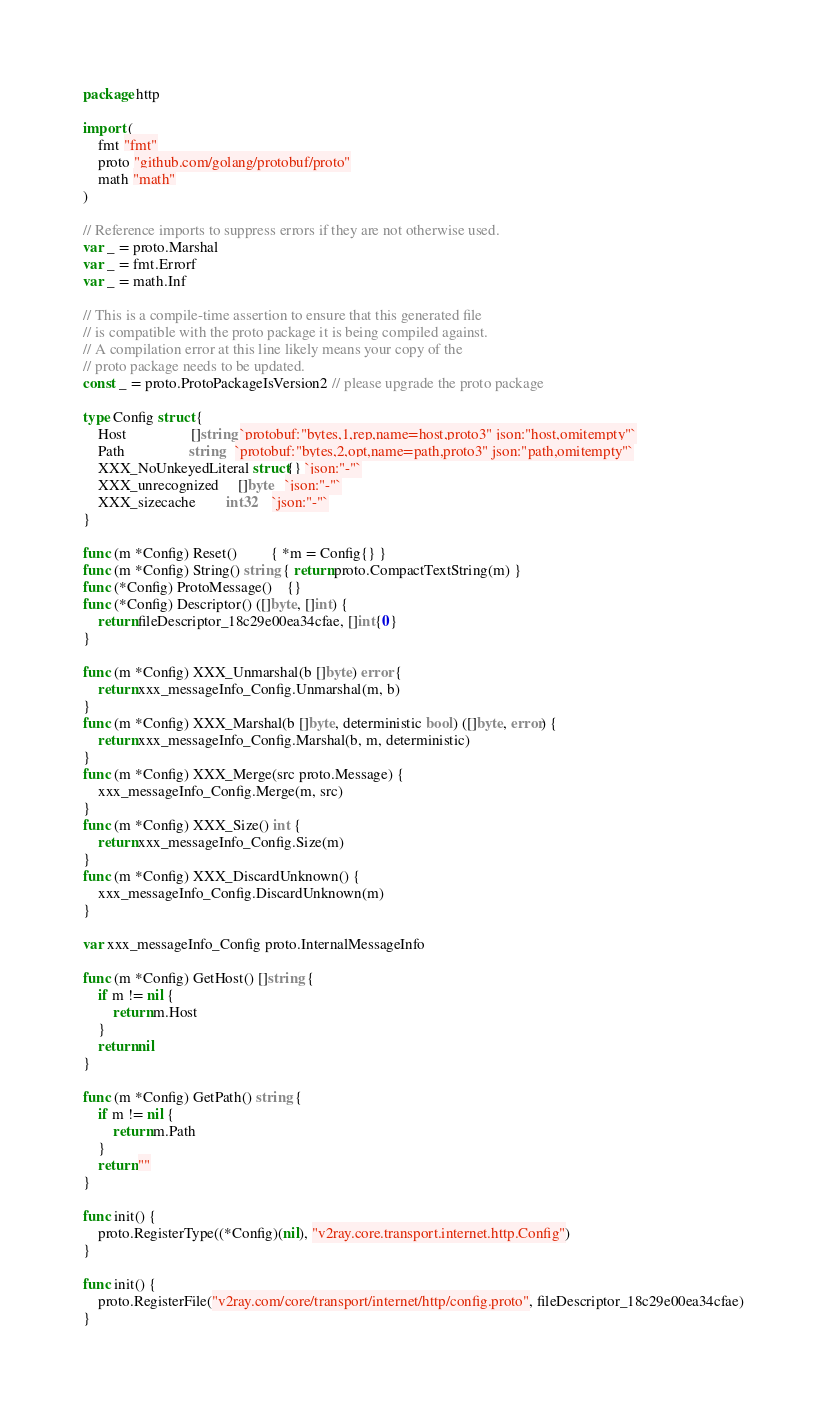Convert code to text. <code><loc_0><loc_0><loc_500><loc_500><_Go_>package http

import (
	fmt "fmt"
	proto "github.com/golang/protobuf/proto"
	math "math"
)

// Reference imports to suppress errors if they are not otherwise used.
var _ = proto.Marshal
var _ = fmt.Errorf
var _ = math.Inf

// This is a compile-time assertion to ensure that this generated file
// is compatible with the proto package it is being compiled against.
// A compilation error at this line likely means your copy of the
// proto package needs to be updated.
const _ = proto.ProtoPackageIsVersion2 // please upgrade the proto package

type Config struct {
	Host                 []string `protobuf:"bytes,1,rep,name=host,proto3" json:"host,omitempty"`
	Path                 string   `protobuf:"bytes,2,opt,name=path,proto3" json:"path,omitempty"`
	XXX_NoUnkeyedLiteral struct{} `json:"-"`
	XXX_unrecognized     []byte   `json:"-"`
	XXX_sizecache        int32    `json:"-"`
}

func (m *Config) Reset()         { *m = Config{} }
func (m *Config) String() string { return proto.CompactTextString(m) }
func (*Config) ProtoMessage()    {}
func (*Config) Descriptor() ([]byte, []int) {
	return fileDescriptor_18c29e00ea34cfae, []int{0}
}

func (m *Config) XXX_Unmarshal(b []byte) error {
	return xxx_messageInfo_Config.Unmarshal(m, b)
}
func (m *Config) XXX_Marshal(b []byte, deterministic bool) ([]byte, error) {
	return xxx_messageInfo_Config.Marshal(b, m, deterministic)
}
func (m *Config) XXX_Merge(src proto.Message) {
	xxx_messageInfo_Config.Merge(m, src)
}
func (m *Config) XXX_Size() int {
	return xxx_messageInfo_Config.Size(m)
}
func (m *Config) XXX_DiscardUnknown() {
	xxx_messageInfo_Config.DiscardUnknown(m)
}

var xxx_messageInfo_Config proto.InternalMessageInfo

func (m *Config) GetHost() []string {
	if m != nil {
		return m.Host
	}
	return nil
}

func (m *Config) GetPath() string {
	if m != nil {
		return m.Path
	}
	return ""
}

func init() {
	proto.RegisterType((*Config)(nil), "v2ray.core.transport.internet.http.Config")
}

func init() {
	proto.RegisterFile("v2ray.com/core/transport/internet/http/config.proto", fileDescriptor_18c29e00ea34cfae)
}
</code> 